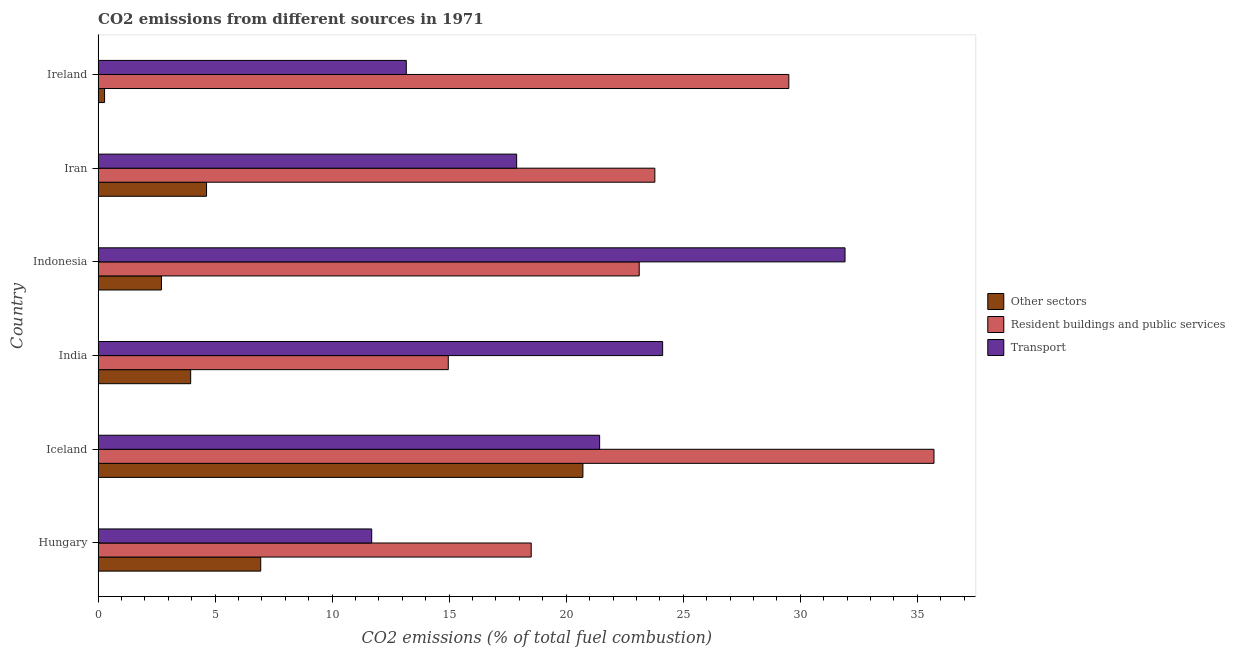How many groups of bars are there?
Make the answer very short. 6. How many bars are there on the 4th tick from the top?
Make the answer very short. 3. How many bars are there on the 6th tick from the bottom?
Keep it short and to the point. 3. In how many cases, is the number of bars for a given country not equal to the number of legend labels?
Ensure brevity in your answer.  0. What is the percentage of co2 emissions from other sectors in Indonesia?
Keep it short and to the point. 2.71. Across all countries, what is the maximum percentage of co2 emissions from resident buildings and public services?
Your response must be concise. 35.71. Across all countries, what is the minimum percentage of co2 emissions from other sectors?
Provide a succinct answer. 0.28. In which country was the percentage of co2 emissions from other sectors maximum?
Offer a terse response. Iceland. In which country was the percentage of co2 emissions from resident buildings and public services minimum?
Provide a succinct answer. India. What is the total percentage of co2 emissions from resident buildings and public services in the graph?
Provide a short and direct response. 145.6. What is the difference between the percentage of co2 emissions from resident buildings and public services in Iceland and that in India?
Offer a terse response. 20.75. What is the difference between the percentage of co2 emissions from other sectors in Hungary and the percentage of co2 emissions from transport in Iran?
Make the answer very short. -10.94. What is the average percentage of co2 emissions from other sectors per country?
Provide a short and direct response. 6.54. What is the difference between the percentage of co2 emissions from transport and percentage of co2 emissions from other sectors in Indonesia?
Keep it short and to the point. 29.21. Is the percentage of co2 emissions from resident buildings and public services in Iran less than that in Ireland?
Give a very brief answer. Yes. Is the difference between the percentage of co2 emissions from other sectors in India and Indonesia greater than the difference between the percentage of co2 emissions from transport in India and Indonesia?
Provide a succinct answer. Yes. What is the difference between the highest and the second highest percentage of co2 emissions from transport?
Provide a succinct answer. 7.79. What is the difference between the highest and the lowest percentage of co2 emissions from resident buildings and public services?
Give a very brief answer. 20.75. Is the sum of the percentage of co2 emissions from transport in Hungary and Iran greater than the maximum percentage of co2 emissions from other sectors across all countries?
Ensure brevity in your answer.  Yes. What does the 3rd bar from the top in Hungary represents?
Offer a very short reply. Other sectors. What does the 3rd bar from the bottom in Ireland represents?
Your answer should be compact. Transport. Is it the case that in every country, the sum of the percentage of co2 emissions from other sectors and percentage of co2 emissions from resident buildings and public services is greater than the percentage of co2 emissions from transport?
Your response must be concise. No. How many countries are there in the graph?
Ensure brevity in your answer.  6. Where does the legend appear in the graph?
Your answer should be compact. Center right. How many legend labels are there?
Your response must be concise. 3. What is the title of the graph?
Your response must be concise. CO2 emissions from different sources in 1971. What is the label or title of the X-axis?
Provide a short and direct response. CO2 emissions (% of total fuel combustion). What is the CO2 emissions (% of total fuel combustion) in Other sectors in Hungary?
Provide a short and direct response. 6.95. What is the CO2 emissions (% of total fuel combustion) of Resident buildings and public services in Hungary?
Give a very brief answer. 18.5. What is the CO2 emissions (% of total fuel combustion) of Transport in Hungary?
Keep it short and to the point. 11.69. What is the CO2 emissions (% of total fuel combustion) in Other sectors in Iceland?
Ensure brevity in your answer.  20.71. What is the CO2 emissions (% of total fuel combustion) in Resident buildings and public services in Iceland?
Your response must be concise. 35.71. What is the CO2 emissions (% of total fuel combustion) of Transport in Iceland?
Your answer should be compact. 21.43. What is the CO2 emissions (% of total fuel combustion) of Other sectors in India?
Ensure brevity in your answer.  3.95. What is the CO2 emissions (% of total fuel combustion) of Resident buildings and public services in India?
Your response must be concise. 14.96. What is the CO2 emissions (% of total fuel combustion) of Transport in India?
Your answer should be compact. 24.12. What is the CO2 emissions (% of total fuel combustion) of Other sectors in Indonesia?
Your answer should be compact. 2.71. What is the CO2 emissions (% of total fuel combustion) in Resident buildings and public services in Indonesia?
Your answer should be compact. 23.12. What is the CO2 emissions (% of total fuel combustion) in Transport in Indonesia?
Keep it short and to the point. 31.91. What is the CO2 emissions (% of total fuel combustion) of Other sectors in Iran?
Ensure brevity in your answer.  4.63. What is the CO2 emissions (% of total fuel combustion) of Resident buildings and public services in Iran?
Offer a terse response. 23.79. What is the CO2 emissions (% of total fuel combustion) of Transport in Iran?
Make the answer very short. 17.88. What is the CO2 emissions (% of total fuel combustion) of Other sectors in Ireland?
Offer a terse response. 0.28. What is the CO2 emissions (% of total fuel combustion) of Resident buildings and public services in Ireland?
Provide a short and direct response. 29.51. What is the CO2 emissions (% of total fuel combustion) of Transport in Ireland?
Your answer should be very brief. 13.17. Across all countries, what is the maximum CO2 emissions (% of total fuel combustion) in Other sectors?
Your answer should be compact. 20.71. Across all countries, what is the maximum CO2 emissions (% of total fuel combustion) of Resident buildings and public services?
Keep it short and to the point. 35.71. Across all countries, what is the maximum CO2 emissions (% of total fuel combustion) of Transport?
Give a very brief answer. 31.91. Across all countries, what is the minimum CO2 emissions (% of total fuel combustion) of Other sectors?
Offer a terse response. 0.28. Across all countries, what is the minimum CO2 emissions (% of total fuel combustion) of Resident buildings and public services?
Provide a short and direct response. 14.96. Across all countries, what is the minimum CO2 emissions (% of total fuel combustion) of Transport?
Your answer should be very brief. 11.69. What is the total CO2 emissions (% of total fuel combustion) in Other sectors in the graph?
Your answer should be very brief. 39.23. What is the total CO2 emissions (% of total fuel combustion) in Resident buildings and public services in the graph?
Give a very brief answer. 145.6. What is the total CO2 emissions (% of total fuel combustion) of Transport in the graph?
Give a very brief answer. 120.2. What is the difference between the CO2 emissions (% of total fuel combustion) of Other sectors in Hungary and that in Iceland?
Offer a terse response. -13.77. What is the difference between the CO2 emissions (% of total fuel combustion) in Resident buildings and public services in Hungary and that in Iceland?
Provide a succinct answer. -17.21. What is the difference between the CO2 emissions (% of total fuel combustion) of Transport in Hungary and that in Iceland?
Give a very brief answer. -9.74. What is the difference between the CO2 emissions (% of total fuel combustion) in Other sectors in Hungary and that in India?
Make the answer very short. 2.99. What is the difference between the CO2 emissions (% of total fuel combustion) of Resident buildings and public services in Hungary and that in India?
Your answer should be compact. 3.54. What is the difference between the CO2 emissions (% of total fuel combustion) of Transport in Hungary and that in India?
Your answer should be very brief. -12.43. What is the difference between the CO2 emissions (% of total fuel combustion) of Other sectors in Hungary and that in Indonesia?
Offer a terse response. 4.24. What is the difference between the CO2 emissions (% of total fuel combustion) in Resident buildings and public services in Hungary and that in Indonesia?
Your answer should be very brief. -4.62. What is the difference between the CO2 emissions (% of total fuel combustion) in Transport in Hungary and that in Indonesia?
Provide a short and direct response. -20.22. What is the difference between the CO2 emissions (% of total fuel combustion) of Other sectors in Hungary and that in Iran?
Keep it short and to the point. 2.31. What is the difference between the CO2 emissions (% of total fuel combustion) of Resident buildings and public services in Hungary and that in Iran?
Offer a terse response. -5.28. What is the difference between the CO2 emissions (% of total fuel combustion) of Transport in Hungary and that in Iran?
Keep it short and to the point. -6.19. What is the difference between the CO2 emissions (% of total fuel combustion) of Other sectors in Hungary and that in Ireland?
Give a very brief answer. 6.67. What is the difference between the CO2 emissions (% of total fuel combustion) of Resident buildings and public services in Hungary and that in Ireland?
Offer a terse response. -11.01. What is the difference between the CO2 emissions (% of total fuel combustion) of Transport in Hungary and that in Ireland?
Provide a short and direct response. -1.48. What is the difference between the CO2 emissions (% of total fuel combustion) of Other sectors in Iceland and that in India?
Give a very brief answer. 16.76. What is the difference between the CO2 emissions (% of total fuel combustion) of Resident buildings and public services in Iceland and that in India?
Ensure brevity in your answer.  20.75. What is the difference between the CO2 emissions (% of total fuel combustion) of Transport in Iceland and that in India?
Your answer should be compact. -2.69. What is the difference between the CO2 emissions (% of total fuel combustion) in Other sectors in Iceland and that in Indonesia?
Your answer should be very brief. 18.01. What is the difference between the CO2 emissions (% of total fuel combustion) in Resident buildings and public services in Iceland and that in Indonesia?
Ensure brevity in your answer.  12.59. What is the difference between the CO2 emissions (% of total fuel combustion) in Transport in Iceland and that in Indonesia?
Your response must be concise. -10.49. What is the difference between the CO2 emissions (% of total fuel combustion) in Other sectors in Iceland and that in Iran?
Keep it short and to the point. 16.08. What is the difference between the CO2 emissions (% of total fuel combustion) in Resident buildings and public services in Iceland and that in Iran?
Provide a succinct answer. 11.93. What is the difference between the CO2 emissions (% of total fuel combustion) in Transport in Iceland and that in Iran?
Offer a very short reply. 3.55. What is the difference between the CO2 emissions (% of total fuel combustion) in Other sectors in Iceland and that in Ireland?
Offer a very short reply. 20.44. What is the difference between the CO2 emissions (% of total fuel combustion) of Resident buildings and public services in Iceland and that in Ireland?
Offer a terse response. 6.2. What is the difference between the CO2 emissions (% of total fuel combustion) of Transport in Iceland and that in Ireland?
Offer a terse response. 8.26. What is the difference between the CO2 emissions (% of total fuel combustion) in Other sectors in India and that in Indonesia?
Offer a very short reply. 1.25. What is the difference between the CO2 emissions (% of total fuel combustion) of Resident buildings and public services in India and that in Indonesia?
Ensure brevity in your answer.  -8.16. What is the difference between the CO2 emissions (% of total fuel combustion) of Transport in India and that in Indonesia?
Ensure brevity in your answer.  -7.79. What is the difference between the CO2 emissions (% of total fuel combustion) in Other sectors in India and that in Iran?
Keep it short and to the point. -0.68. What is the difference between the CO2 emissions (% of total fuel combustion) of Resident buildings and public services in India and that in Iran?
Your response must be concise. -8.83. What is the difference between the CO2 emissions (% of total fuel combustion) of Transport in India and that in Iran?
Offer a terse response. 6.24. What is the difference between the CO2 emissions (% of total fuel combustion) in Other sectors in India and that in Ireland?
Your answer should be very brief. 3.68. What is the difference between the CO2 emissions (% of total fuel combustion) in Resident buildings and public services in India and that in Ireland?
Provide a succinct answer. -14.55. What is the difference between the CO2 emissions (% of total fuel combustion) in Transport in India and that in Ireland?
Your answer should be very brief. 10.95. What is the difference between the CO2 emissions (% of total fuel combustion) of Other sectors in Indonesia and that in Iran?
Keep it short and to the point. -1.93. What is the difference between the CO2 emissions (% of total fuel combustion) in Resident buildings and public services in Indonesia and that in Iran?
Make the answer very short. -0.67. What is the difference between the CO2 emissions (% of total fuel combustion) of Transport in Indonesia and that in Iran?
Make the answer very short. 14.03. What is the difference between the CO2 emissions (% of total fuel combustion) in Other sectors in Indonesia and that in Ireland?
Offer a very short reply. 2.43. What is the difference between the CO2 emissions (% of total fuel combustion) in Resident buildings and public services in Indonesia and that in Ireland?
Keep it short and to the point. -6.39. What is the difference between the CO2 emissions (% of total fuel combustion) of Transport in Indonesia and that in Ireland?
Provide a succinct answer. 18.75. What is the difference between the CO2 emissions (% of total fuel combustion) in Other sectors in Iran and that in Ireland?
Your answer should be compact. 4.36. What is the difference between the CO2 emissions (% of total fuel combustion) of Resident buildings and public services in Iran and that in Ireland?
Provide a short and direct response. -5.72. What is the difference between the CO2 emissions (% of total fuel combustion) of Transport in Iran and that in Ireland?
Your answer should be compact. 4.72. What is the difference between the CO2 emissions (% of total fuel combustion) in Other sectors in Hungary and the CO2 emissions (% of total fuel combustion) in Resident buildings and public services in Iceland?
Provide a succinct answer. -28.77. What is the difference between the CO2 emissions (% of total fuel combustion) of Other sectors in Hungary and the CO2 emissions (% of total fuel combustion) of Transport in Iceland?
Ensure brevity in your answer.  -14.48. What is the difference between the CO2 emissions (% of total fuel combustion) in Resident buildings and public services in Hungary and the CO2 emissions (% of total fuel combustion) in Transport in Iceland?
Your response must be concise. -2.92. What is the difference between the CO2 emissions (% of total fuel combustion) of Other sectors in Hungary and the CO2 emissions (% of total fuel combustion) of Resident buildings and public services in India?
Your answer should be compact. -8.01. What is the difference between the CO2 emissions (% of total fuel combustion) of Other sectors in Hungary and the CO2 emissions (% of total fuel combustion) of Transport in India?
Offer a terse response. -17.17. What is the difference between the CO2 emissions (% of total fuel combustion) of Resident buildings and public services in Hungary and the CO2 emissions (% of total fuel combustion) of Transport in India?
Your response must be concise. -5.62. What is the difference between the CO2 emissions (% of total fuel combustion) of Other sectors in Hungary and the CO2 emissions (% of total fuel combustion) of Resident buildings and public services in Indonesia?
Your response must be concise. -16.17. What is the difference between the CO2 emissions (% of total fuel combustion) of Other sectors in Hungary and the CO2 emissions (% of total fuel combustion) of Transport in Indonesia?
Keep it short and to the point. -24.97. What is the difference between the CO2 emissions (% of total fuel combustion) of Resident buildings and public services in Hungary and the CO2 emissions (% of total fuel combustion) of Transport in Indonesia?
Ensure brevity in your answer.  -13.41. What is the difference between the CO2 emissions (% of total fuel combustion) of Other sectors in Hungary and the CO2 emissions (% of total fuel combustion) of Resident buildings and public services in Iran?
Provide a succinct answer. -16.84. What is the difference between the CO2 emissions (% of total fuel combustion) of Other sectors in Hungary and the CO2 emissions (% of total fuel combustion) of Transport in Iran?
Provide a short and direct response. -10.94. What is the difference between the CO2 emissions (% of total fuel combustion) in Resident buildings and public services in Hungary and the CO2 emissions (% of total fuel combustion) in Transport in Iran?
Your answer should be compact. 0.62. What is the difference between the CO2 emissions (% of total fuel combustion) in Other sectors in Hungary and the CO2 emissions (% of total fuel combustion) in Resident buildings and public services in Ireland?
Your response must be concise. -22.56. What is the difference between the CO2 emissions (% of total fuel combustion) of Other sectors in Hungary and the CO2 emissions (% of total fuel combustion) of Transport in Ireland?
Your answer should be very brief. -6.22. What is the difference between the CO2 emissions (% of total fuel combustion) of Resident buildings and public services in Hungary and the CO2 emissions (% of total fuel combustion) of Transport in Ireland?
Offer a very short reply. 5.34. What is the difference between the CO2 emissions (% of total fuel combustion) in Other sectors in Iceland and the CO2 emissions (% of total fuel combustion) in Resident buildings and public services in India?
Your response must be concise. 5.75. What is the difference between the CO2 emissions (% of total fuel combustion) in Other sectors in Iceland and the CO2 emissions (% of total fuel combustion) in Transport in India?
Keep it short and to the point. -3.41. What is the difference between the CO2 emissions (% of total fuel combustion) in Resident buildings and public services in Iceland and the CO2 emissions (% of total fuel combustion) in Transport in India?
Your answer should be very brief. 11.59. What is the difference between the CO2 emissions (% of total fuel combustion) in Other sectors in Iceland and the CO2 emissions (% of total fuel combustion) in Resident buildings and public services in Indonesia?
Offer a terse response. -2.41. What is the difference between the CO2 emissions (% of total fuel combustion) of Other sectors in Iceland and the CO2 emissions (% of total fuel combustion) of Transport in Indonesia?
Provide a short and direct response. -11.2. What is the difference between the CO2 emissions (% of total fuel combustion) in Resident buildings and public services in Iceland and the CO2 emissions (% of total fuel combustion) in Transport in Indonesia?
Your response must be concise. 3.8. What is the difference between the CO2 emissions (% of total fuel combustion) of Other sectors in Iceland and the CO2 emissions (% of total fuel combustion) of Resident buildings and public services in Iran?
Offer a very short reply. -3.07. What is the difference between the CO2 emissions (% of total fuel combustion) in Other sectors in Iceland and the CO2 emissions (% of total fuel combustion) in Transport in Iran?
Give a very brief answer. 2.83. What is the difference between the CO2 emissions (% of total fuel combustion) of Resident buildings and public services in Iceland and the CO2 emissions (% of total fuel combustion) of Transport in Iran?
Keep it short and to the point. 17.83. What is the difference between the CO2 emissions (% of total fuel combustion) in Other sectors in Iceland and the CO2 emissions (% of total fuel combustion) in Resident buildings and public services in Ireland?
Your answer should be compact. -8.8. What is the difference between the CO2 emissions (% of total fuel combustion) of Other sectors in Iceland and the CO2 emissions (% of total fuel combustion) of Transport in Ireland?
Provide a short and direct response. 7.55. What is the difference between the CO2 emissions (% of total fuel combustion) in Resident buildings and public services in Iceland and the CO2 emissions (% of total fuel combustion) in Transport in Ireland?
Offer a very short reply. 22.55. What is the difference between the CO2 emissions (% of total fuel combustion) in Other sectors in India and the CO2 emissions (% of total fuel combustion) in Resident buildings and public services in Indonesia?
Your response must be concise. -19.17. What is the difference between the CO2 emissions (% of total fuel combustion) of Other sectors in India and the CO2 emissions (% of total fuel combustion) of Transport in Indonesia?
Your answer should be very brief. -27.96. What is the difference between the CO2 emissions (% of total fuel combustion) of Resident buildings and public services in India and the CO2 emissions (% of total fuel combustion) of Transport in Indonesia?
Your answer should be very brief. -16.95. What is the difference between the CO2 emissions (% of total fuel combustion) in Other sectors in India and the CO2 emissions (% of total fuel combustion) in Resident buildings and public services in Iran?
Offer a terse response. -19.83. What is the difference between the CO2 emissions (% of total fuel combustion) in Other sectors in India and the CO2 emissions (% of total fuel combustion) in Transport in Iran?
Offer a very short reply. -13.93. What is the difference between the CO2 emissions (% of total fuel combustion) in Resident buildings and public services in India and the CO2 emissions (% of total fuel combustion) in Transport in Iran?
Provide a succinct answer. -2.92. What is the difference between the CO2 emissions (% of total fuel combustion) of Other sectors in India and the CO2 emissions (% of total fuel combustion) of Resident buildings and public services in Ireland?
Offer a terse response. -25.56. What is the difference between the CO2 emissions (% of total fuel combustion) in Other sectors in India and the CO2 emissions (% of total fuel combustion) in Transport in Ireland?
Your answer should be compact. -9.21. What is the difference between the CO2 emissions (% of total fuel combustion) in Resident buildings and public services in India and the CO2 emissions (% of total fuel combustion) in Transport in Ireland?
Give a very brief answer. 1.79. What is the difference between the CO2 emissions (% of total fuel combustion) in Other sectors in Indonesia and the CO2 emissions (% of total fuel combustion) in Resident buildings and public services in Iran?
Offer a terse response. -21.08. What is the difference between the CO2 emissions (% of total fuel combustion) in Other sectors in Indonesia and the CO2 emissions (% of total fuel combustion) in Transport in Iran?
Offer a very short reply. -15.18. What is the difference between the CO2 emissions (% of total fuel combustion) in Resident buildings and public services in Indonesia and the CO2 emissions (% of total fuel combustion) in Transport in Iran?
Your answer should be compact. 5.24. What is the difference between the CO2 emissions (% of total fuel combustion) in Other sectors in Indonesia and the CO2 emissions (% of total fuel combustion) in Resident buildings and public services in Ireland?
Ensure brevity in your answer.  -26.81. What is the difference between the CO2 emissions (% of total fuel combustion) of Other sectors in Indonesia and the CO2 emissions (% of total fuel combustion) of Transport in Ireland?
Your response must be concise. -10.46. What is the difference between the CO2 emissions (% of total fuel combustion) of Resident buildings and public services in Indonesia and the CO2 emissions (% of total fuel combustion) of Transport in Ireland?
Keep it short and to the point. 9.95. What is the difference between the CO2 emissions (% of total fuel combustion) of Other sectors in Iran and the CO2 emissions (% of total fuel combustion) of Resident buildings and public services in Ireland?
Offer a terse response. -24.88. What is the difference between the CO2 emissions (% of total fuel combustion) of Other sectors in Iran and the CO2 emissions (% of total fuel combustion) of Transport in Ireland?
Keep it short and to the point. -8.53. What is the difference between the CO2 emissions (% of total fuel combustion) of Resident buildings and public services in Iran and the CO2 emissions (% of total fuel combustion) of Transport in Ireland?
Make the answer very short. 10.62. What is the average CO2 emissions (% of total fuel combustion) in Other sectors per country?
Provide a short and direct response. 6.54. What is the average CO2 emissions (% of total fuel combustion) of Resident buildings and public services per country?
Provide a short and direct response. 24.27. What is the average CO2 emissions (% of total fuel combustion) in Transport per country?
Provide a succinct answer. 20.03. What is the difference between the CO2 emissions (% of total fuel combustion) in Other sectors and CO2 emissions (% of total fuel combustion) in Resident buildings and public services in Hungary?
Your answer should be very brief. -11.56. What is the difference between the CO2 emissions (% of total fuel combustion) in Other sectors and CO2 emissions (% of total fuel combustion) in Transport in Hungary?
Make the answer very short. -4.74. What is the difference between the CO2 emissions (% of total fuel combustion) in Resident buildings and public services and CO2 emissions (% of total fuel combustion) in Transport in Hungary?
Your answer should be very brief. 6.81. What is the difference between the CO2 emissions (% of total fuel combustion) in Other sectors and CO2 emissions (% of total fuel combustion) in Resident buildings and public services in Iceland?
Give a very brief answer. -15. What is the difference between the CO2 emissions (% of total fuel combustion) in Other sectors and CO2 emissions (% of total fuel combustion) in Transport in Iceland?
Provide a succinct answer. -0.71. What is the difference between the CO2 emissions (% of total fuel combustion) in Resident buildings and public services and CO2 emissions (% of total fuel combustion) in Transport in Iceland?
Keep it short and to the point. 14.29. What is the difference between the CO2 emissions (% of total fuel combustion) of Other sectors and CO2 emissions (% of total fuel combustion) of Resident buildings and public services in India?
Offer a very short reply. -11.01. What is the difference between the CO2 emissions (% of total fuel combustion) of Other sectors and CO2 emissions (% of total fuel combustion) of Transport in India?
Provide a succinct answer. -20.17. What is the difference between the CO2 emissions (% of total fuel combustion) in Resident buildings and public services and CO2 emissions (% of total fuel combustion) in Transport in India?
Make the answer very short. -9.16. What is the difference between the CO2 emissions (% of total fuel combustion) in Other sectors and CO2 emissions (% of total fuel combustion) in Resident buildings and public services in Indonesia?
Make the answer very short. -20.41. What is the difference between the CO2 emissions (% of total fuel combustion) of Other sectors and CO2 emissions (% of total fuel combustion) of Transport in Indonesia?
Give a very brief answer. -29.21. What is the difference between the CO2 emissions (% of total fuel combustion) in Resident buildings and public services and CO2 emissions (% of total fuel combustion) in Transport in Indonesia?
Provide a succinct answer. -8.79. What is the difference between the CO2 emissions (% of total fuel combustion) in Other sectors and CO2 emissions (% of total fuel combustion) in Resident buildings and public services in Iran?
Provide a succinct answer. -19.16. What is the difference between the CO2 emissions (% of total fuel combustion) in Other sectors and CO2 emissions (% of total fuel combustion) in Transport in Iran?
Your answer should be compact. -13.25. What is the difference between the CO2 emissions (% of total fuel combustion) in Resident buildings and public services and CO2 emissions (% of total fuel combustion) in Transport in Iran?
Give a very brief answer. 5.9. What is the difference between the CO2 emissions (% of total fuel combustion) in Other sectors and CO2 emissions (% of total fuel combustion) in Resident buildings and public services in Ireland?
Offer a very short reply. -29.24. What is the difference between the CO2 emissions (% of total fuel combustion) in Other sectors and CO2 emissions (% of total fuel combustion) in Transport in Ireland?
Your answer should be very brief. -12.89. What is the difference between the CO2 emissions (% of total fuel combustion) of Resident buildings and public services and CO2 emissions (% of total fuel combustion) of Transport in Ireland?
Make the answer very short. 16.34. What is the ratio of the CO2 emissions (% of total fuel combustion) in Other sectors in Hungary to that in Iceland?
Provide a succinct answer. 0.34. What is the ratio of the CO2 emissions (% of total fuel combustion) of Resident buildings and public services in Hungary to that in Iceland?
Your answer should be very brief. 0.52. What is the ratio of the CO2 emissions (% of total fuel combustion) in Transport in Hungary to that in Iceland?
Your answer should be very brief. 0.55. What is the ratio of the CO2 emissions (% of total fuel combustion) of Other sectors in Hungary to that in India?
Your answer should be very brief. 1.76. What is the ratio of the CO2 emissions (% of total fuel combustion) in Resident buildings and public services in Hungary to that in India?
Your answer should be compact. 1.24. What is the ratio of the CO2 emissions (% of total fuel combustion) of Transport in Hungary to that in India?
Offer a terse response. 0.48. What is the ratio of the CO2 emissions (% of total fuel combustion) in Other sectors in Hungary to that in Indonesia?
Your answer should be compact. 2.57. What is the ratio of the CO2 emissions (% of total fuel combustion) of Resident buildings and public services in Hungary to that in Indonesia?
Keep it short and to the point. 0.8. What is the ratio of the CO2 emissions (% of total fuel combustion) of Transport in Hungary to that in Indonesia?
Your answer should be compact. 0.37. What is the ratio of the CO2 emissions (% of total fuel combustion) in Other sectors in Hungary to that in Iran?
Your answer should be compact. 1.5. What is the ratio of the CO2 emissions (% of total fuel combustion) in Resident buildings and public services in Hungary to that in Iran?
Provide a short and direct response. 0.78. What is the ratio of the CO2 emissions (% of total fuel combustion) of Transport in Hungary to that in Iran?
Make the answer very short. 0.65. What is the ratio of the CO2 emissions (% of total fuel combustion) in Other sectors in Hungary to that in Ireland?
Provide a succinct answer. 25.15. What is the ratio of the CO2 emissions (% of total fuel combustion) of Resident buildings and public services in Hungary to that in Ireland?
Keep it short and to the point. 0.63. What is the ratio of the CO2 emissions (% of total fuel combustion) of Transport in Hungary to that in Ireland?
Keep it short and to the point. 0.89. What is the ratio of the CO2 emissions (% of total fuel combustion) in Other sectors in Iceland to that in India?
Keep it short and to the point. 5.24. What is the ratio of the CO2 emissions (% of total fuel combustion) in Resident buildings and public services in Iceland to that in India?
Your answer should be very brief. 2.39. What is the ratio of the CO2 emissions (% of total fuel combustion) of Transport in Iceland to that in India?
Keep it short and to the point. 0.89. What is the ratio of the CO2 emissions (% of total fuel combustion) in Other sectors in Iceland to that in Indonesia?
Your response must be concise. 7.66. What is the ratio of the CO2 emissions (% of total fuel combustion) in Resident buildings and public services in Iceland to that in Indonesia?
Ensure brevity in your answer.  1.54. What is the ratio of the CO2 emissions (% of total fuel combustion) of Transport in Iceland to that in Indonesia?
Your answer should be compact. 0.67. What is the ratio of the CO2 emissions (% of total fuel combustion) in Other sectors in Iceland to that in Iran?
Offer a very short reply. 4.47. What is the ratio of the CO2 emissions (% of total fuel combustion) of Resident buildings and public services in Iceland to that in Iran?
Provide a succinct answer. 1.5. What is the ratio of the CO2 emissions (% of total fuel combustion) of Transport in Iceland to that in Iran?
Make the answer very short. 1.2. What is the ratio of the CO2 emissions (% of total fuel combustion) of Other sectors in Iceland to that in Ireland?
Your answer should be very brief. 74.99. What is the ratio of the CO2 emissions (% of total fuel combustion) in Resident buildings and public services in Iceland to that in Ireland?
Offer a very short reply. 1.21. What is the ratio of the CO2 emissions (% of total fuel combustion) of Transport in Iceland to that in Ireland?
Offer a terse response. 1.63. What is the ratio of the CO2 emissions (% of total fuel combustion) of Other sectors in India to that in Indonesia?
Your response must be concise. 1.46. What is the ratio of the CO2 emissions (% of total fuel combustion) in Resident buildings and public services in India to that in Indonesia?
Keep it short and to the point. 0.65. What is the ratio of the CO2 emissions (% of total fuel combustion) of Transport in India to that in Indonesia?
Provide a short and direct response. 0.76. What is the ratio of the CO2 emissions (% of total fuel combustion) in Other sectors in India to that in Iran?
Provide a succinct answer. 0.85. What is the ratio of the CO2 emissions (% of total fuel combustion) of Resident buildings and public services in India to that in Iran?
Offer a terse response. 0.63. What is the ratio of the CO2 emissions (% of total fuel combustion) in Transport in India to that in Iran?
Offer a terse response. 1.35. What is the ratio of the CO2 emissions (% of total fuel combustion) of Other sectors in India to that in Ireland?
Your response must be concise. 14.32. What is the ratio of the CO2 emissions (% of total fuel combustion) of Resident buildings and public services in India to that in Ireland?
Your answer should be very brief. 0.51. What is the ratio of the CO2 emissions (% of total fuel combustion) of Transport in India to that in Ireland?
Provide a short and direct response. 1.83. What is the ratio of the CO2 emissions (% of total fuel combustion) of Other sectors in Indonesia to that in Iran?
Offer a terse response. 0.58. What is the ratio of the CO2 emissions (% of total fuel combustion) of Resident buildings and public services in Indonesia to that in Iran?
Ensure brevity in your answer.  0.97. What is the ratio of the CO2 emissions (% of total fuel combustion) of Transport in Indonesia to that in Iran?
Ensure brevity in your answer.  1.78. What is the ratio of the CO2 emissions (% of total fuel combustion) in Other sectors in Indonesia to that in Ireland?
Offer a terse response. 9.8. What is the ratio of the CO2 emissions (% of total fuel combustion) in Resident buildings and public services in Indonesia to that in Ireland?
Your answer should be compact. 0.78. What is the ratio of the CO2 emissions (% of total fuel combustion) in Transport in Indonesia to that in Ireland?
Provide a short and direct response. 2.42. What is the ratio of the CO2 emissions (% of total fuel combustion) of Other sectors in Iran to that in Ireland?
Make the answer very short. 16.77. What is the ratio of the CO2 emissions (% of total fuel combustion) in Resident buildings and public services in Iran to that in Ireland?
Provide a short and direct response. 0.81. What is the ratio of the CO2 emissions (% of total fuel combustion) of Transport in Iran to that in Ireland?
Your answer should be very brief. 1.36. What is the difference between the highest and the second highest CO2 emissions (% of total fuel combustion) of Other sectors?
Offer a very short reply. 13.77. What is the difference between the highest and the second highest CO2 emissions (% of total fuel combustion) in Resident buildings and public services?
Ensure brevity in your answer.  6.2. What is the difference between the highest and the second highest CO2 emissions (% of total fuel combustion) in Transport?
Keep it short and to the point. 7.79. What is the difference between the highest and the lowest CO2 emissions (% of total fuel combustion) of Other sectors?
Your answer should be compact. 20.44. What is the difference between the highest and the lowest CO2 emissions (% of total fuel combustion) in Resident buildings and public services?
Keep it short and to the point. 20.75. What is the difference between the highest and the lowest CO2 emissions (% of total fuel combustion) in Transport?
Make the answer very short. 20.22. 